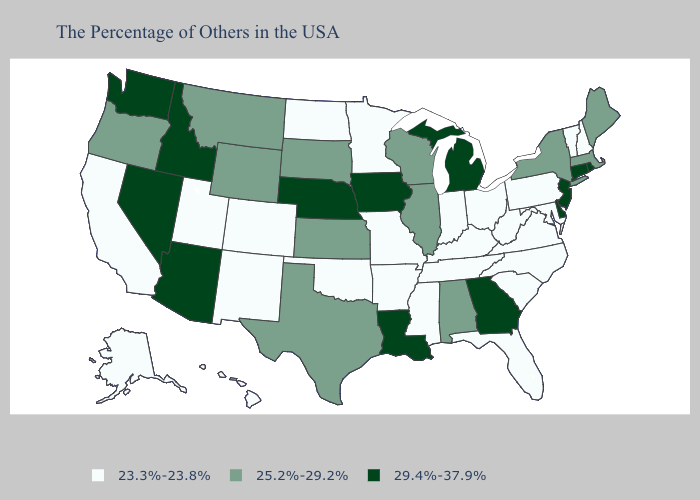Which states have the lowest value in the USA?
Short answer required. New Hampshire, Vermont, Maryland, Pennsylvania, Virginia, North Carolina, South Carolina, West Virginia, Ohio, Florida, Kentucky, Indiana, Tennessee, Mississippi, Missouri, Arkansas, Minnesota, Oklahoma, North Dakota, Colorado, New Mexico, Utah, California, Alaska, Hawaii. Does Minnesota have the same value as Rhode Island?
Answer briefly. No. Does Rhode Island have the lowest value in the USA?
Answer briefly. No. Name the states that have a value in the range 25.2%-29.2%?
Concise answer only. Maine, Massachusetts, New York, Alabama, Wisconsin, Illinois, Kansas, Texas, South Dakota, Wyoming, Montana, Oregon. Is the legend a continuous bar?
Be succinct. No. Name the states that have a value in the range 25.2%-29.2%?
Give a very brief answer. Maine, Massachusetts, New York, Alabama, Wisconsin, Illinois, Kansas, Texas, South Dakota, Wyoming, Montana, Oregon. What is the value of Georgia?
Be succinct. 29.4%-37.9%. Name the states that have a value in the range 29.4%-37.9%?
Keep it brief. Rhode Island, Connecticut, New Jersey, Delaware, Georgia, Michigan, Louisiana, Iowa, Nebraska, Arizona, Idaho, Nevada, Washington. Name the states that have a value in the range 23.3%-23.8%?
Quick response, please. New Hampshire, Vermont, Maryland, Pennsylvania, Virginia, North Carolina, South Carolina, West Virginia, Ohio, Florida, Kentucky, Indiana, Tennessee, Mississippi, Missouri, Arkansas, Minnesota, Oklahoma, North Dakota, Colorado, New Mexico, Utah, California, Alaska, Hawaii. Which states hav the highest value in the South?
Be succinct. Delaware, Georgia, Louisiana. Does Oklahoma have the lowest value in the USA?
Quick response, please. Yes. Does the first symbol in the legend represent the smallest category?
Give a very brief answer. Yes. Which states have the lowest value in the USA?
Give a very brief answer. New Hampshire, Vermont, Maryland, Pennsylvania, Virginia, North Carolina, South Carolina, West Virginia, Ohio, Florida, Kentucky, Indiana, Tennessee, Mississippi, Missouri, Arkansas, Minnesota, Oklahoma, North Dakota, Colorado, New Mexico, Utah, California, Alaska, Hawaii. What is the highest value in the MidWest ?
Write a very short answer. 29.4%-37.9%. How many symbols are there in the legend?
Answer briefly. 3. 